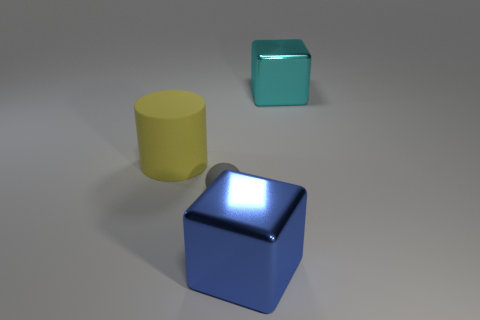Add 2 big shiny objects. How many objects exist? 6 Subtract all cylinders. How many objects are left? 3 Add 1 large yellow cylinders. How many large yellow cylinders are left? 2 Add 4 big red metallic balls. How many big red metallic balls exist? 4 Subtract 0 red balls. How many objects are left? 4 Subtract all large matte things. Subtract all large yellow things. How many objects are left? 2 